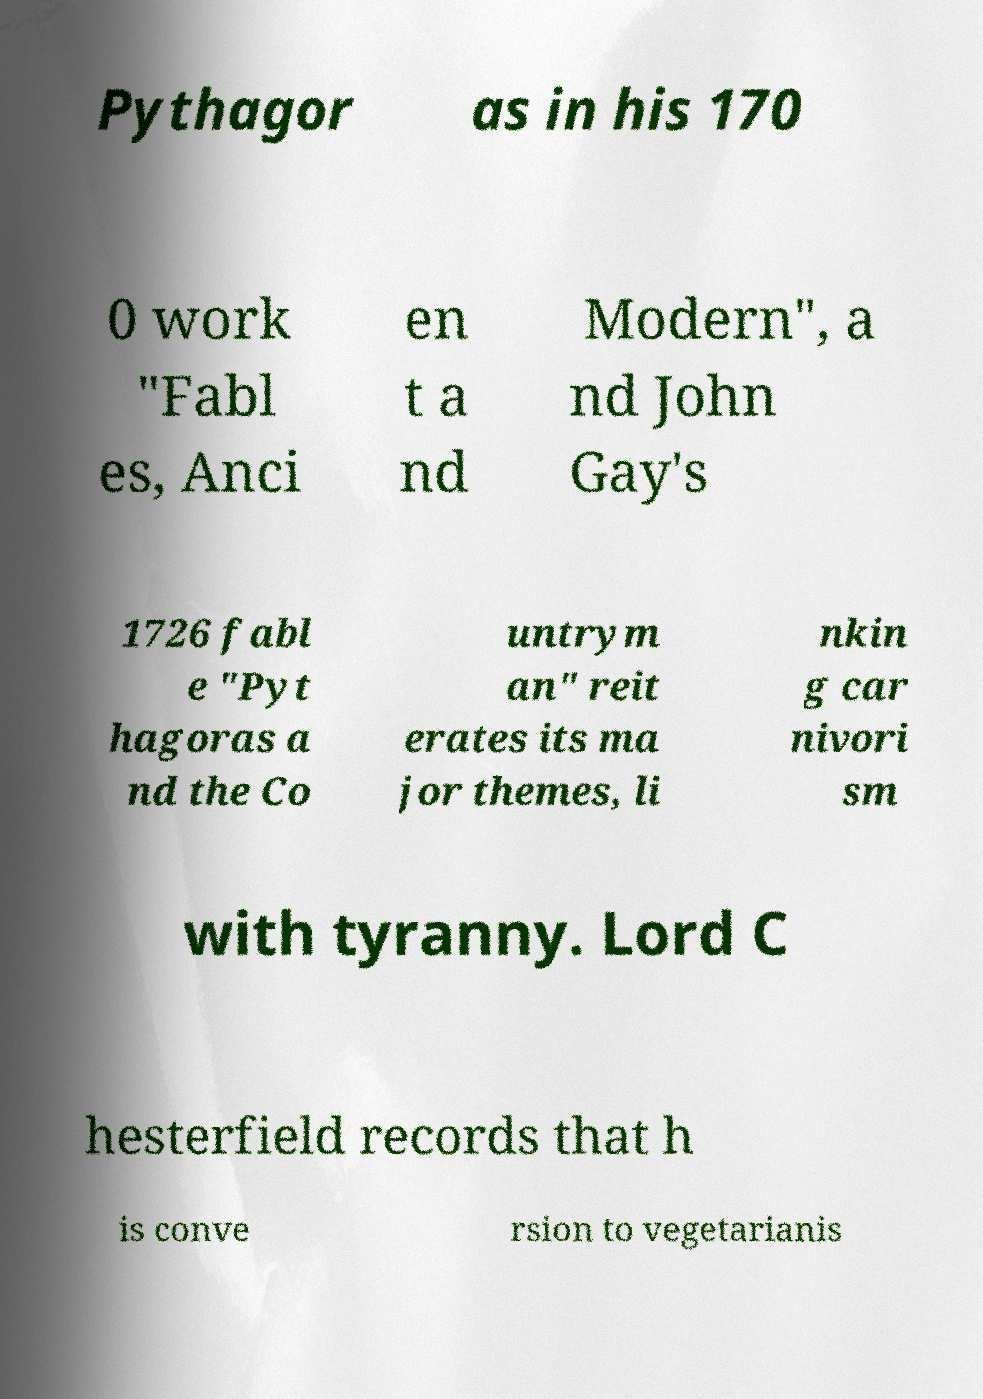I need the written content from this picture converted into text. Can you do that? Pythagor as in his 170 0 work "Fabl es, Anci en t a nd Modern", a nd John Gay's 1726 fabl e "Pyt hagoras a nd the Co untrym an" reit erates its ma jor themes, li nkin g car nivori sm with tyranny. Lord C hesterfield records that h is conve rsion to vegetarianis 